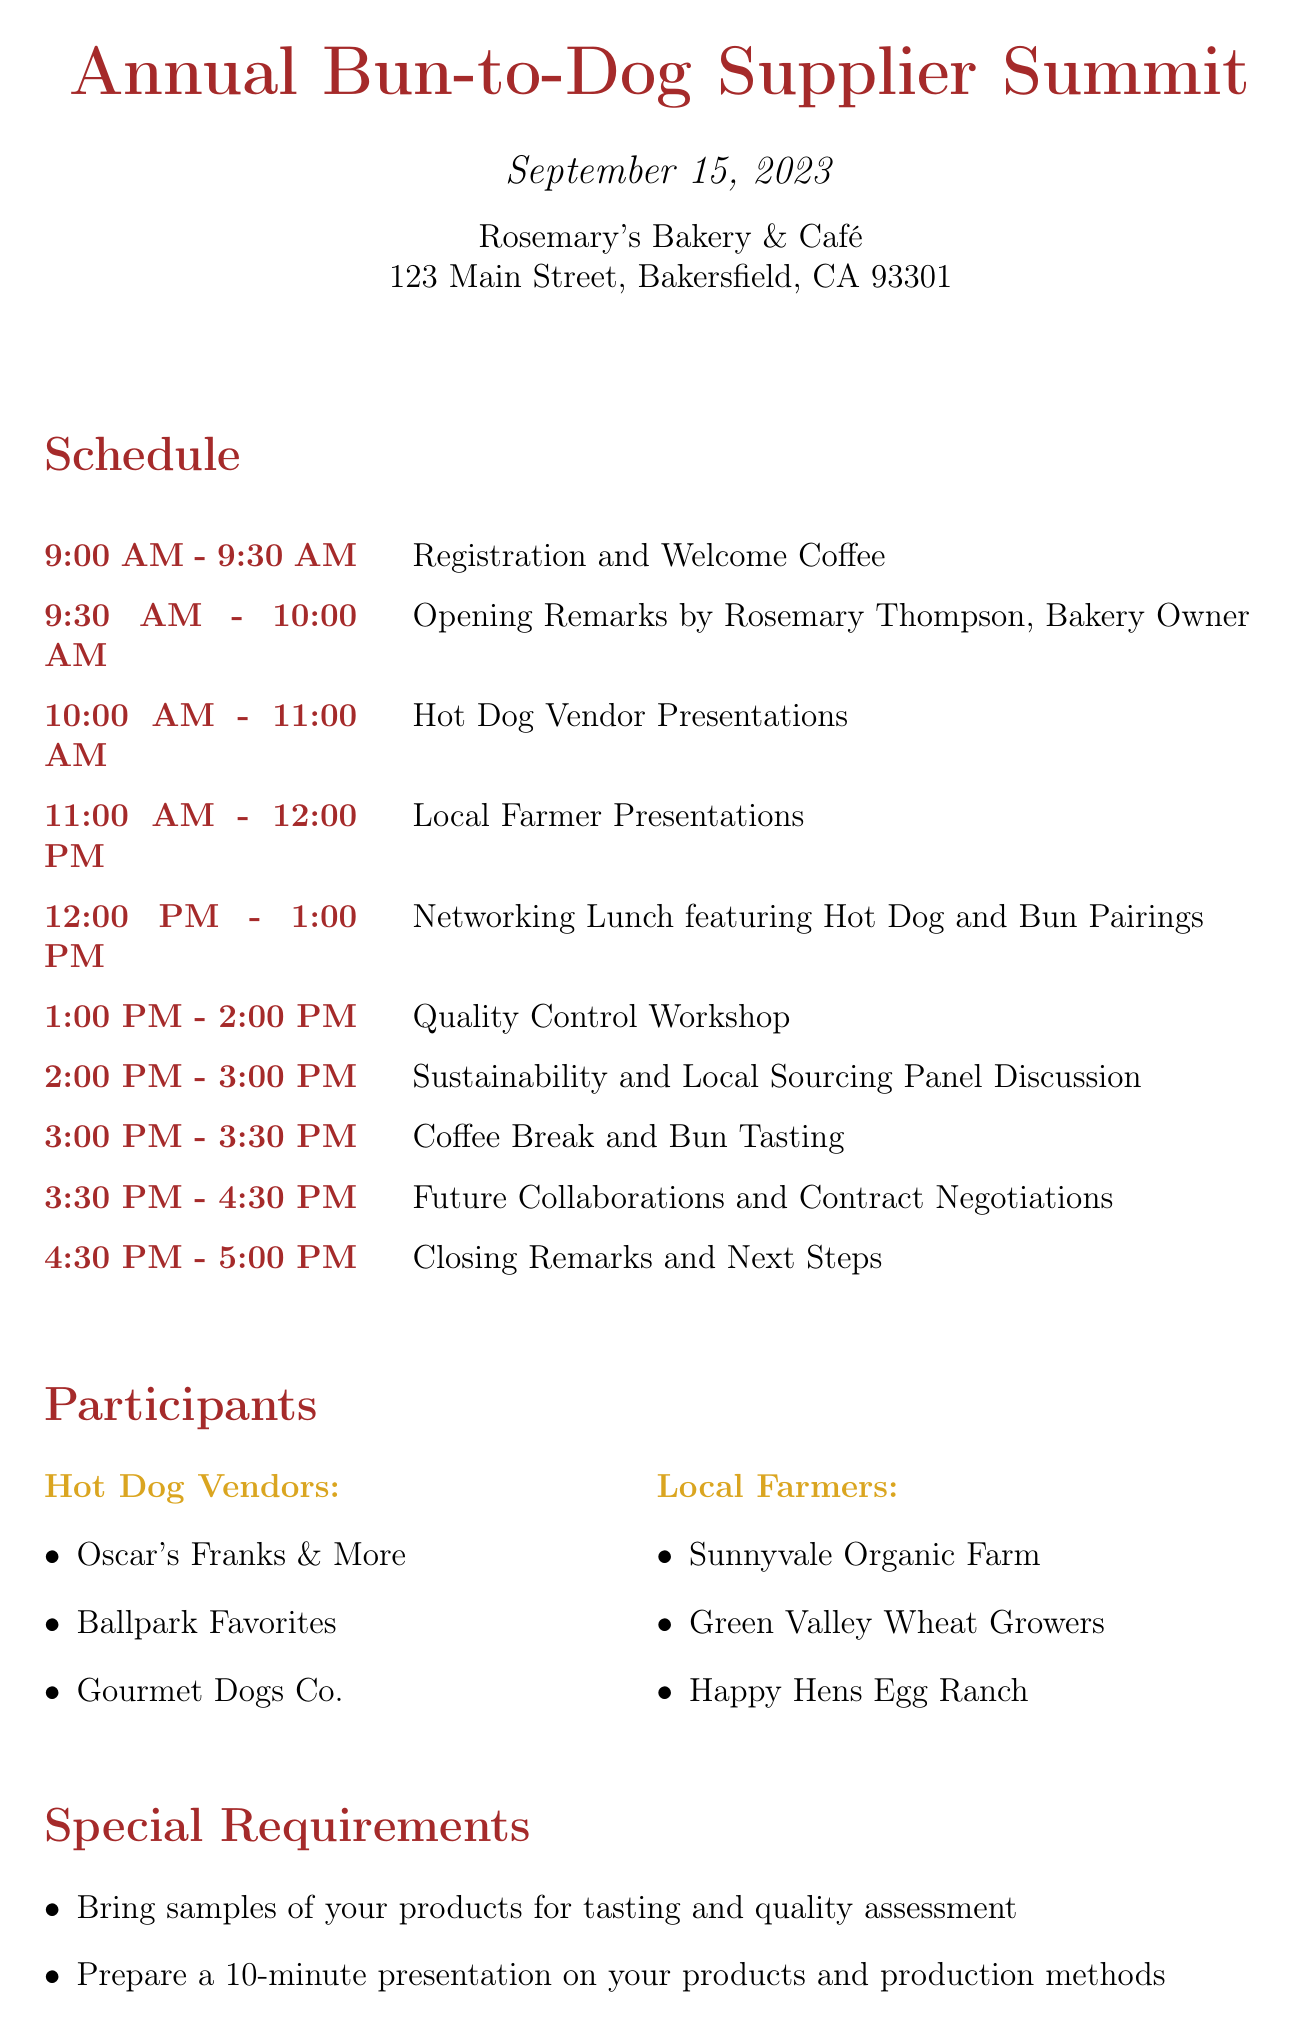What is the date of the event? The date of the event is explicitly stated in the document, which is September 15, 2023.
Answer: September 15, 2023 Who is the contact person for the event? The document clearly lists Rosemary Thompson as the contact person for the event.
Answer: Rosemary Thompson What time does the Quality Control Workshop start? The schedule indicates that the Quality Control Workshop begins at 1:00 PM.
Answer: 1:00 PM How many hot dog vendors are participating? The participants section enumerates three hot dog vendors, confirming the total count.
Answer: Three What is the focus of the panel discussion? The document specifies that the panel discussion focuses on Sustainability and Local Sourcing.
Answer: Sustainability and Local Sourcing What special requirement is mentioned regarding product samples? One of the special requirements is to bring samples for tasting and quality assessment, as stated in the document.
Answer: Bring samples of your products for tasting and quality assessment Who will give the opening remarks? The document clearly identifies Rosemary Thompson as the speaker for the opening remarks.
Answer: Rosemary Thompson What activity follows the Local Farmer Presentations? The schedule indicates that the next activity after the Local Farmer Presentations is a Networking Lunch featuring Hot Dog and Bun Pairings.
Answer: Networking Lunch featuring Hot Dog and Bun Pairings 